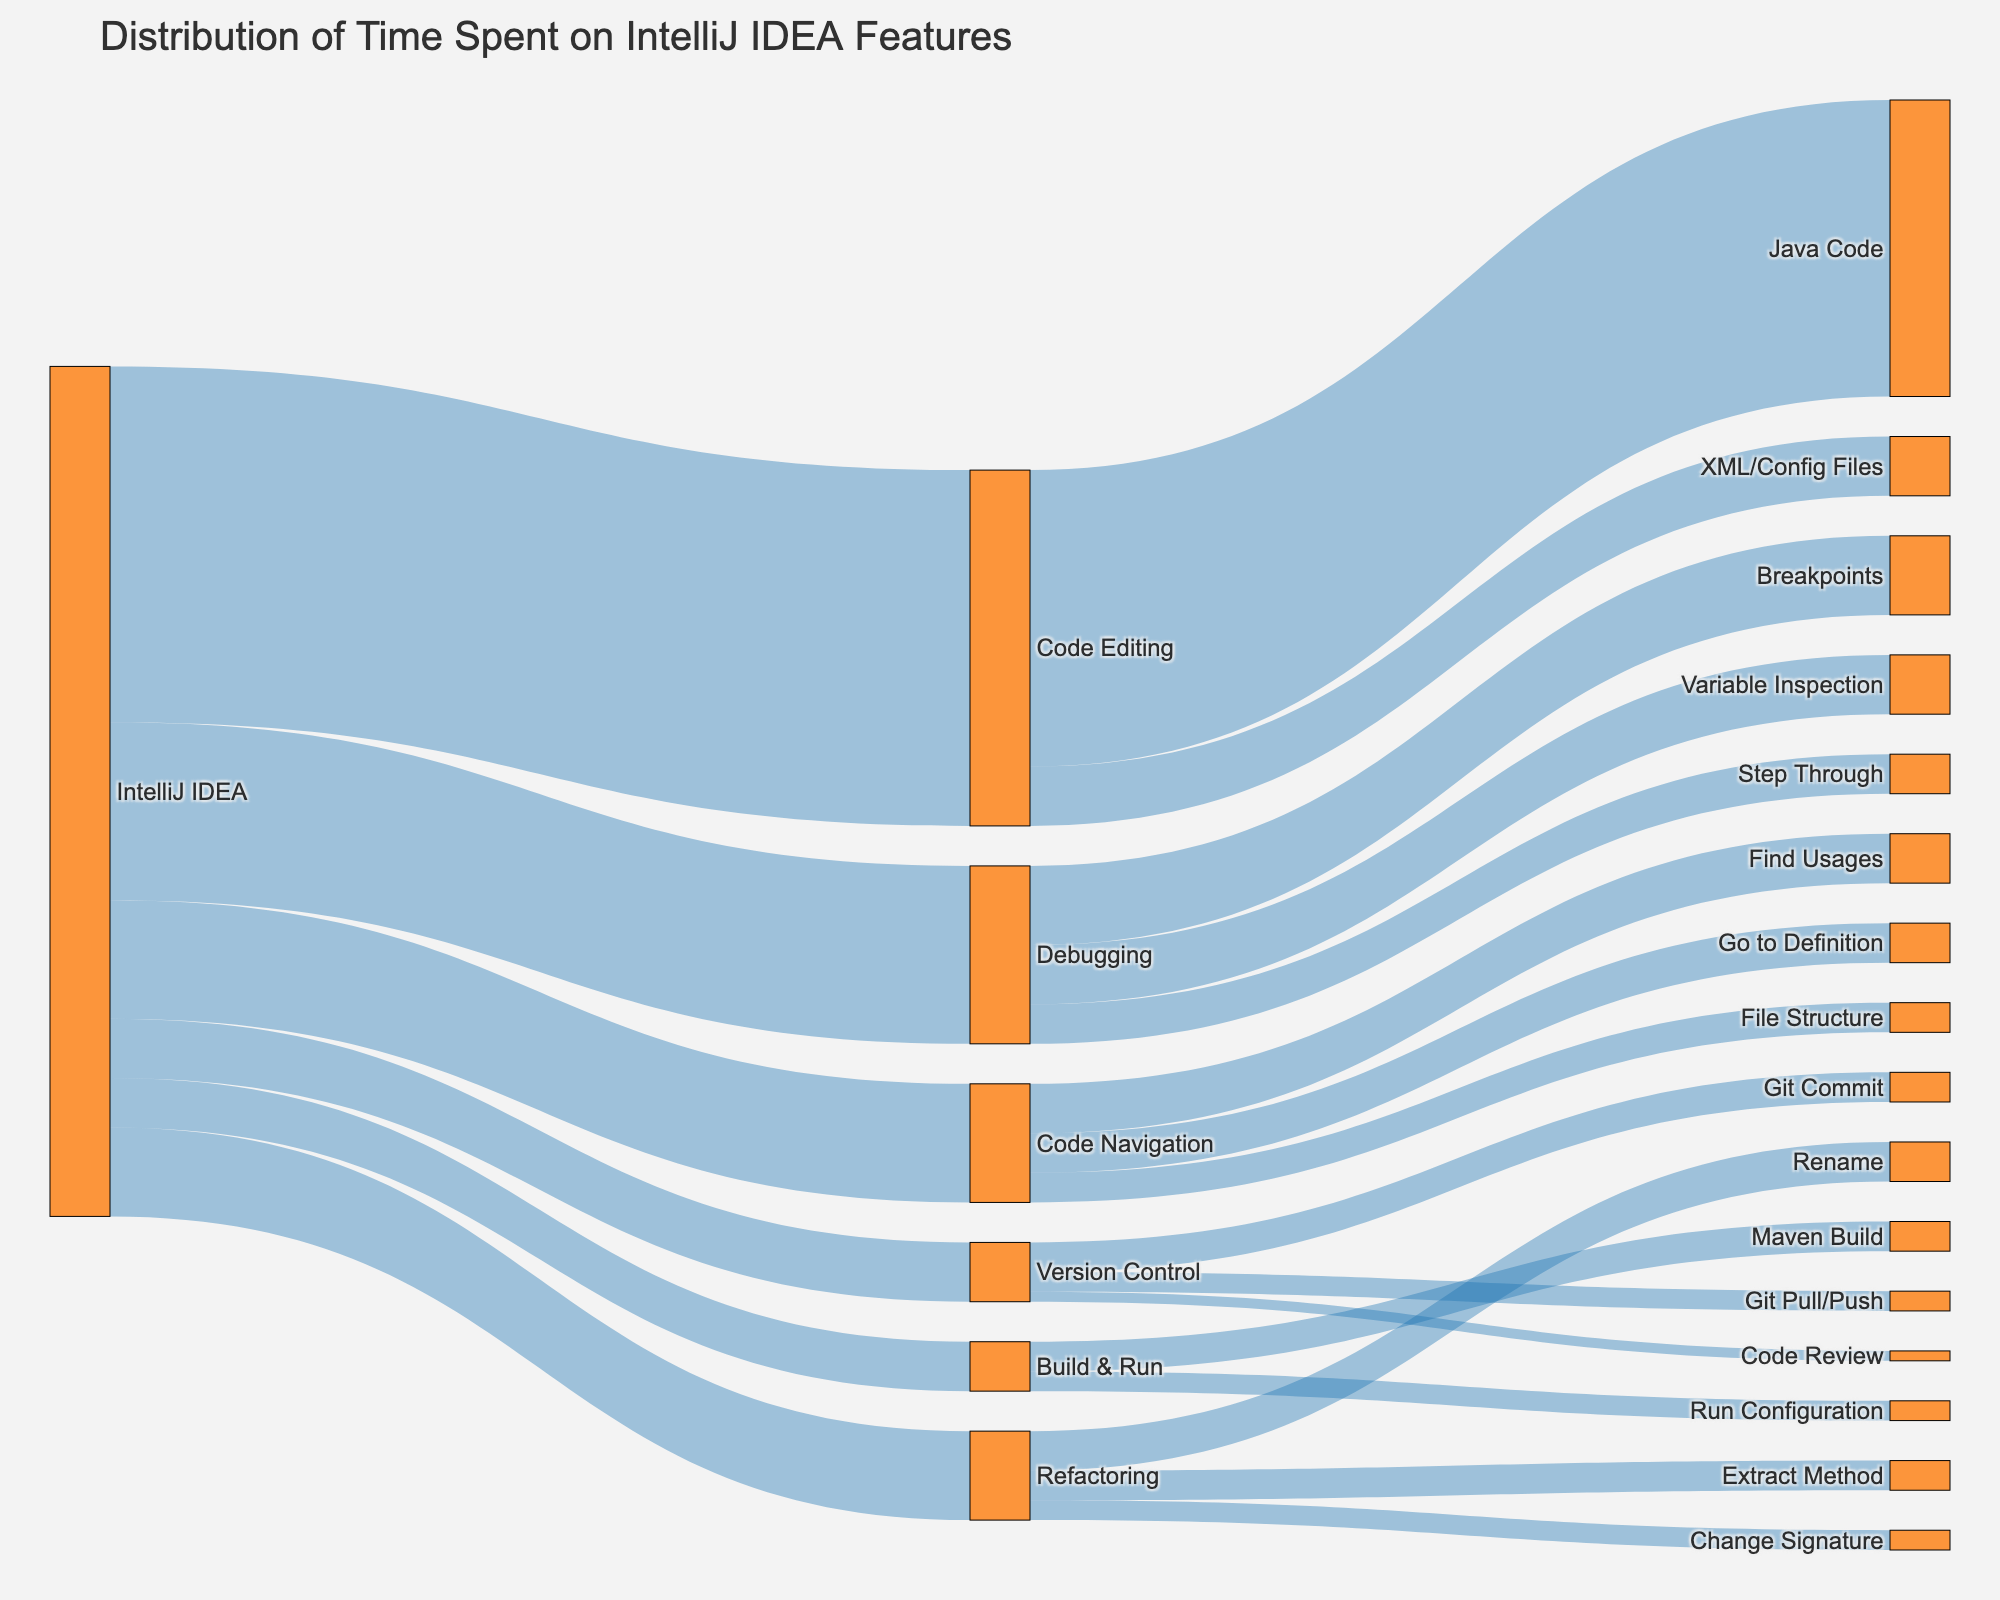What is the title of the figure? The title is usually placed at the top of the figure, summarizing its purpose and giving context to the viewer. In this case, it reads "Distribution of Time Spent on IntelliJ IDEA Features".
Answer: Distribution of Time Spent on IntelliJ IDEA Features What is the total amount of time spent on Code Editing? To find the total time spent on Code Editing, locate the sum of all values flowing into the "Code Editing" node: 150 (Java Code) + 30 (XML/Config Files) = 180.
Answer: 180 minutes How much time is spent on Debugging compared to Code Navigation? To compare the time spent on Debugging and Code Navigation, we look at the values: Debugging (90 minutes) and Code Navigation (60 minutes). Debugging has 30 minutes more than Code Navigation.
Answer: Debugging has 30 minutes more than Code Navigation Which Refactoring activity takes the most time? For Refactoring, identify the largest value directed from the "Refactoring" node. The values are: Rename (20), Extract Method (15), and Change Signature (10). Rename has the highest value.
Answer: Rename What is the least time-consuming activity in Build & Run? Look at the two activities under Build & Run: Maven Build (15) and Run Configuration (10). Run Configuration is the least time-consuming.
Answer: Run Configuration How does time spent on Version Control activities compare overall with Refactoring? First, sum the time for all activities in Version Control: Git Commit (15) + Git Pull/Push (10) + Code Review (5) = 30 minutes. Next, sum the time for all activities in Refactoring: Rename (20) + Extract Method (15) + Change Signature (10) = 45 minutes. Refactoring has 15 minutes more than Version Control.
Answer: Refactoring has 15 minutes more than Version Control How much more time is spent on Java Code compared to XML/Config Files within Code Editing? Identify the values for Java Code (150) and XML/Config Files (30). Subtract XML/Config Files from Java Code: 150 - 30 = 120.
Answer: 120 minutes more Calculate the average time spent on all activities in Debugging. Sum all the values under Debugging: Breakpoints (40) + Variable Inspection (30) + Step Through (20) = 90. Divide by the number of activities: 90/3 = 30.
Answer: 30 minutes Compare the total time spent on Build & Run activities with Refactoring activities. Sum the values for Build & Run: Maven Build (15) + Run Configuration (10) = 25. Sum the values for Refactoring: Rename (20) + Extract Method (15) + Change Signature (10) = 45. Refactoring has 20 minutes more.
Answer: Refactoring has 20 minutes more What is the average time spent on Code Navigation activities? To find the average, sum all the times for Code Navigation activities: Find Usages (25), Go to Definition (20), File Structure (15). The sum is 25 + 20 + 15 = 60. The average is 60/3 = 20.
Answer: 20 minutes 